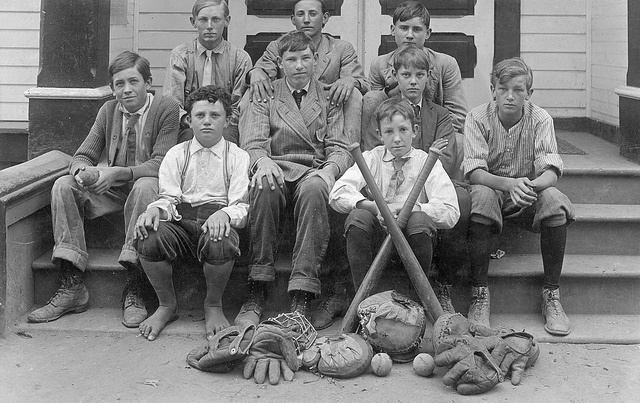Describe the objects in this image and their specific colors. I can see people in lightgray, gray, darkgray, and black tones, people in lightgray, gray, darkgray, and black tones, people in lightgray, gray, darkgray, and black tones, people in lightgray, darkgray, gray, and black tones, and people in lightgray, darkgray, gray, and black tones in this image. 